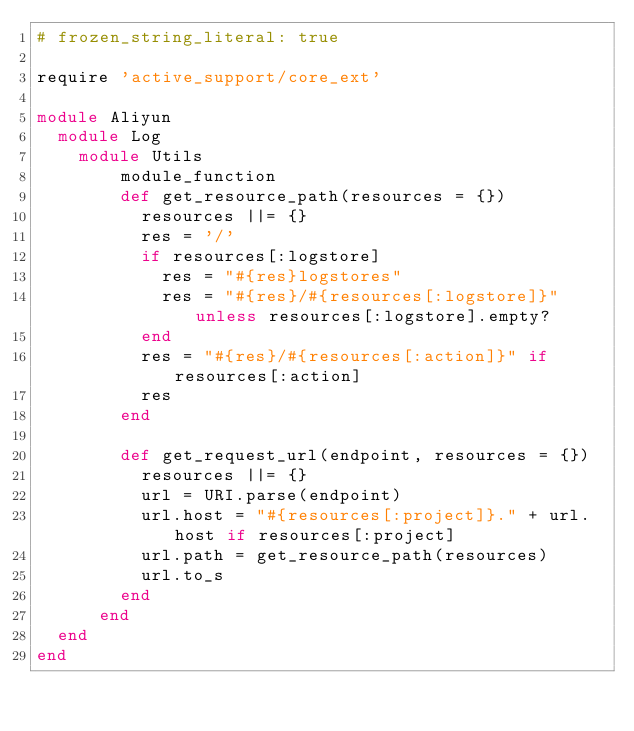Convert code to text. <code><loc_0><loc_0><loc_500><loc_500><_Ruby_># frozen_string_literal: true

require 'active_support/core_ext'

module Aliyun
  module Log
  	module Utils
	  	module_function
	  	def get_resource_path(resources = {})
	      resources ||= {}
	      res = '/'
	      if resources[:logstore]
	        res = "#{res}logstores"
	        res = "#{res}/#{resources[:logstore]}" unless resources[:logstore].empty?
	      end
	      res = "#{res}/#{resources[:action]}" if resources[:action]
	      res
	    end

	    def get_request_url(endpoint, resources = {})
	      resources ||= {}
	      url = URI.parse(endpoint)
	      url.host = "#{resources[:project]}." + url.host if resources[:project]
	      url.path = get_resource_path(resources)
	      url.to_s
	    end
	  end
  end
end
</code> 